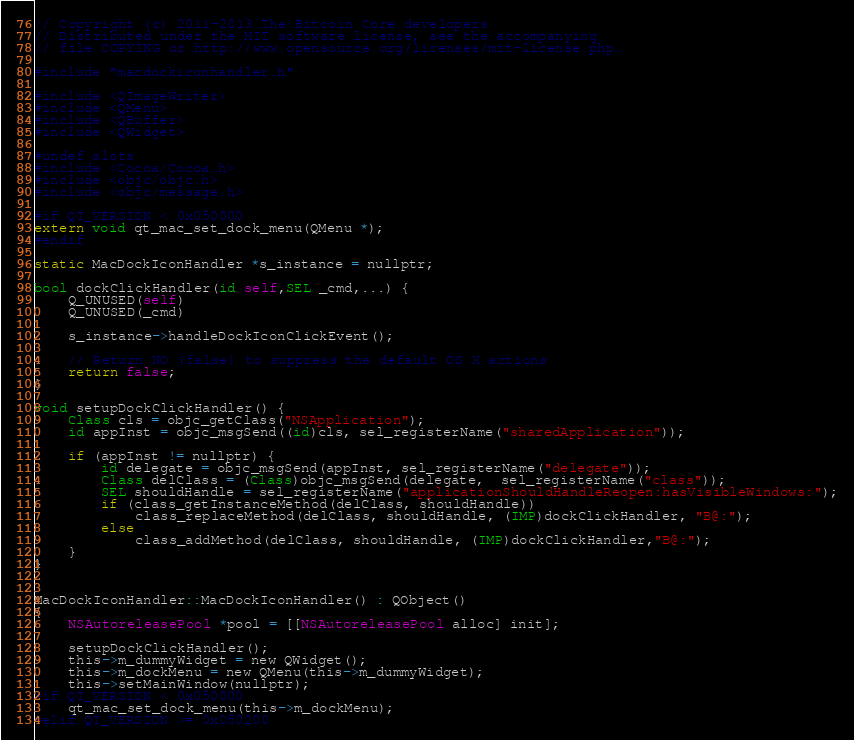<code> <loc_0><loc_0><loc_500><loc_500><_ObjectiveC_>// Copyright (c) 2011-2013 The Bitcoin Core developers
// Distributed under the MIT software license, see the accompanying
// file COPYING or http://www.opensource.org/licenses/mit-license.php.

#include "macdockiconhandler.h"

#include <QImageWriter>
#include <QMenu>
#include <QBuffer>
#include <QWidget>

#undef slots
#include <Cocoa/Cocoa.h>
#include <objc/objc.h>
#include <objc/message.h>

#if QT_VERSION < 0x050000
extern void qt_mac_set_dock_menu(QMenu *);
#endif

static MacDockIconHandler *s_instance = nullptr;

bool dockClickHandler(id self,SEL _cmd,...) {
    Q_UNUSED(self)
    Q_UNUSED(_cmd)
    
    s_instance->handleDockIconClickEvent();
    
    // Return NO (false) to suppress the default OS X actions
    return false;
}

void setupDockClickHandler() {
    Class cls = objc_getClass("NSApplication");
    id appInst = objc_msgSend((id)cls, sel_registerName("sharedApplication"));
    
    if (appInst != nullptr) {
        id delegate = objc_msgSend(appInst, sel_registerName("delegate"));
        Class delClass = (Class)objc_msgSend(delegate,  sel_registerName("class"));
        SEL shouldHandle = sel_registerName("applicationShouldHandleReopen:hasVisibleWindows:");
        if (class_getInstanceMethod(delClass, shouldHandle))
            class_replaceMethod(delClass, shouldHandle, (IMP)dockClickHandler, "B@:");
        else
            class_addMethod(delClass, shouldHandle, (IMP)dockClickHandler,"B@:");
    }
}


MacDockIconHandler::MacDockIconHandler() : QObject()
{
    NSAutoreleasePool *pool = [[NSAutoreleasePool alloc] init];

    setupDockClickHandler();
    this->m_dummyWidget = new QWidget();
    this->m_dockMenu = new QMenu(this->m_dummyWidget);
    this->setMainWindow(nullptr);
#if QT_VERSION < 0x050000
    qt_mac_set_dock_menu(this->m_dockMenu);
#elif QT_VERSION >= 0x050200</code> 